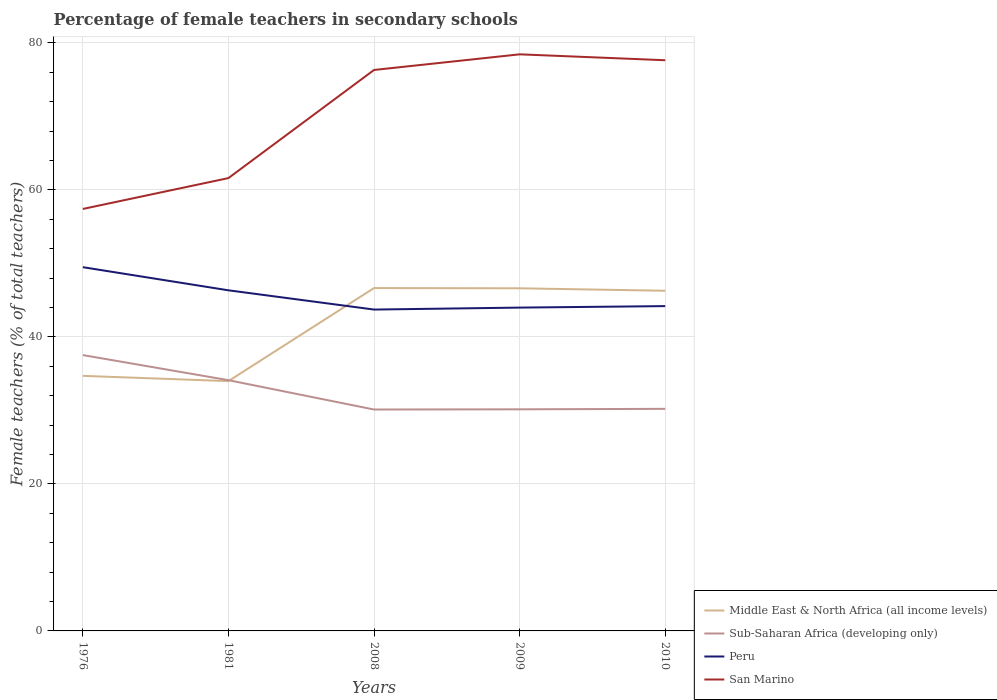How many different coloured lines are there?
Make the answer very short. 4. Is the number of lines equal to the number of legend labels?
Offer a very short reply. Yes. Across all years, what is the maximum percentage of female teachers in Middle East & North Africa (all income levels)?
Ensure brevity in your answer.  33.99. In which year was the percentage of female teachers in Sub-Saharan Africa (developing only) maximum?
Provide a succinct answer. 2008. What is the total percentage of female teachers in Middle East & North Africa (all income levels) in the graph?
Your answer should be compact. 0.72. What is the difference between the highest and the second highest percentage of female teachers in Sub-Saharan Africa (developing only)?
Make the answer very short. 7.41. How many lines are there?
Your response must be concise. 4. How many years are there in the graph?
Your answer should be compact. 5. What is the difference between two consecutive major ticks on the Y-axis?
Provide a succinct answer. 20. Does the graph contain any zero values?
Provide a short and direct response. No. Does the graph contain grids?
Make the answer very short. Yes. How many legend labels are there?
Your answer should be very brief. 4. What is the title of the graph?
Give a very brief answer. Percentage of female teachers in secondary schools. Does "Grenada" appear as one of the legend labels in the graph?
Keep it short and to the point. No. What is the label or title of the Y-axis?
Offer a very short reply. Female teachers (% of total teachers). What is the Female teachers (% of total teachers) of Middle East & North Africa (all income levels) in 1976?
Offer a very short reply. 34.7. What is the Female teachers (% of total teachers) in Sub-Saharan Africa (developing only) in 1976?
Your response must be concise. 37.53. What is the Female teachers (% of total teachers) of Peru in 1976?
Your answer should be very brief. 49.49. What is the Female teachers (% of total teachers) in San Marino in 1976?
Your answer should be very brief. 57.41. What is the Female teachers (% of total teachers) of Middle East & North Africa (all income levels) in 1981?
Provide a succinct answer. 33.99. What is the Female teachers (% of total teachers) in Sub-Saharan Africa (developing only) in 1981?
Your answer should be compact. 34.11. What is the Female teachers (% of total teachers) in Peru in 1981?
Offer a terse response. 46.34. What is the Female teachers (% of total teachers) of San Marino in 1981?
Offer a terse response. 61.61. What is the Female teachers (% of total teachers) of Middle East & North Africa (all income levels) in 2008?
Your response must be concise. 46.65. What is the Female teachers (% of total teachers) of Sub-Saharan Africa (developing only) in 2008?
Keep it short and to the point. 30.12. What is the Female teachers (% of total teachers) of Peru in 2008?
Your answer should be very brief. 43.72. What is the Female teachers (% of total teachers) of San Marino in 2008?
Offer a terse response. 76.32. What is the Female teachers (% of total teachers) of Middle East & North Africa (all income levels) in 2009?
Provide a short and direct response. 46.61. What is the Female teachers (% of total teachers) of Sub-Saharan Africa (developing only) in 2009?
Your response must be concise. 30.15. What is the Female teachers (% of total teachers) in Peru in 2009?
Your answer should be compact. 43.99. What is the Female teachers (% of total teachers) in San Marino in 2009?
Ensure brevity in your answer.  78.44. What is the Female teachers (% of total teachers) of Middle East & North Africa (all income levels) in 2010?
Your answer should be compact. 46.28. What is the Female teachers (% of total teachers) of Sub-Saharan Africa (developing only) in 2010?
Offer a terse response. 30.21. What is the Female teachers (% of total teachers) of Peru in 2010?
Keep it short and to the point. 44.19. What is the Female teachers (% of total teachers) of San Marino in 2010?
Your answer should be very brief. 77.64. Across all years, what is the maximum Female teachers (% of total teachers) of Middle East & North Africa (all income levels)?
Keep it short and to the point. 46.65. Across all years, what is the maximum Female teachers (% of total teachers) in Sub-Saharan Africa (developing only)?
Your answer should be compact. 37.53. Across all years, what is the maximum Female teachers (% of total teachers) of Peru?
Your response must be concise. 49.49. Across all years, what is the maximum Female teachers (% of total teachers) in San Marino?
Your answer should be very brief. 78.44. Across all years, what is the minimum Female teachers (% of total teachers) in Middle East & North Africa (all income levels)?
Make the answer very short. 33.99. Across all years, what is the minimum Female teachers (% of total teachers) in Sub-Saharan Africa (developing only)?
Make the answer very short. 30.12. Across all years, what is the minimum Female teachers (% of total teachers) of Peru?
Your answer should be compact. 43.72. Across all years, what is the minimum Female teachers (% of total teachers) in San Marino?
Keep it short and to the point. 57.41. What is the total Female teachers (% of total teachers) in Middle East & North Africa (all income levels) in the graph?
Provide a succinct answer. 208.22. What is the total Female teachers (% of total teachers) in Sub-Saharan Africa (developing only) in the graph?
Ensure brevity in your answer.  162.13. What is the total Female teachers (% of total teachers) of Peru in the graph?
Your answer should be very brief. 227.72. What is the total Female teachers (% of total teachers) in San Marino in the graph?
Ensure brevity in your answer.  351.41. What is the difference between the Female teachers (% of total teachers) of Middle East & North Africa (all income levels) in 1976 and that in 1981?
Your answer should be compact. 0.72. What is the difference between the Female teachers (% of total teachers) in Sub-Saharan Africa (developing only) in 1976 and that in 1981?
Make the answer very short. 3.41. What is the difference between the Female teachers (% of total teachers) of Peru in 1976 and that in 1981?
Keep it short and to the point. 3.15. What is the difference between the Female teachers (% of total teachers) in San Marino in 1976 and that in 1981?
Provide a short and direct response. -4.2. What is the difference between the Female teachers (% of total teachers) of Middle East & North Africa (all income levels) in 1976 and that in 2008?
Offer a very short reply. -11.94. What is the difference between the Female teachers (% of total teachers) of Sub-Saharan Africa (developing only) in 1976 and that in 2008?
Provide a succinct answer. 7.41. What is the difference between the Female teachers (% of total teachers) in Peru in 1976 and that in 2008?
Ensure brevity in your answer.  5.77. What is the difference between the Female teachers (% of total teachers) in San Marino in 1976 and that in 2008?
Keep it short and to the point. -18.91. What is the difference between the Female teachers (% of total teachers) of Middle East & North Africa (all income levels) in 1976 and that in 2009?
Make the answer very short. -11.91. What is the difference between the Female teachers (% of total teachers) of Sub-Saharan Africa (developing only) in 1976 and that in 2009?
Ensure brevity in your answer.  7.38. What is the difference between the Female teachers (% of total teachers) of Peru in 1976 and that in 2009?
Your answer should be compact. 5.5. What is the difference between the Female teachers (% of total teachers) of San Marino in 1976 and that in 2009?
Make the answer very short. -21.04. What is the difference between the Female teachers (% of total teachers) in Middle East & North Africa (all income levels) in 1976 and that in 2010?
Offer a very short reply. -11.58. What is the difference between the Female teachers (% of total teachers) in Sub-Saharan Africa (developing only) in 1976 and that in 2010?
Your response must be concise. 7.31. What is the difference between the Female teachers (% of total teachers) in Peru in 1976 and that in 2010?
Keep it short and to the point. 5.3. What is the difference between the Female teachers (% of total teachers) in San Marino in 1976 and that in 2010?
Your answer should be very brief. -20.23. What is the difference between the Female teachers (% of total teachers) in Middle East & North Africa (all income levels) in 1981 and that in 2008?
Provide a succinct answer. -12.66. What is the difference between the Female teachers (% of total teachers) in Sub-Saharan Africa (developing only) in 1981 and that in 2008?
Give a very brief answer. 3.99. What is the difference between the Female teachers (% of total teachers) in Peru in 1981 and that in 2008?
Provide a succinct answer. 2.62. What is the difference between the Female teachers (% of total teachers) in San Marino in 1981 and that in 2008?
Offer a terse response. -14.71. What is the difference between the Female teachers (% of total teachers) of Middle East & North Africa (all income levels) in 1981 and that in 2009?
Ensure brevity in your answer.  -12.63. What is the difference between the Female teachers (% of total teachers) in Sub-Saharan Africa (developing only) in 1981 and that in 2009?
Your response must be concise. 3.96. What is the difference between the Female teachers (% of total teachers) in Peru in 1981 and that in 2009?
Keep it short and to the point. 2.35. What is the difference between the Female teachers (% of total teachers) of San Marino in 1981 and that in 2009?
Your response must be concise. -16.84. What is the difference between the Female teachers (% of total teachers) of Middle East & North Africa (all income levels) in 1981 and that in 2010?
Provide a succinct answer. -12.29. What is the difference between the Female teachers (% of total teachers) in Sub-Saharan Africa (developing only) in 1981 and that in 2010?
Make the answer very short. 3.9. What is the difference between the Female teachers (% of total teachers) of Peru in 1981 and that in 2010?
Your response must be concise. 2.15. What is the difference between the Female teachers (% of total teachers) in San Marino in 1981 and that in 2010?
Make the answer very short. -16.03. What is the difference between the Female teachers (% of total teachers) in Middle East & North Africa (all income levels) in 2008 and that in 2009?
Give a very brief answer. 0.03. What is the difference between the Female teachers (% of total teachers) in Sub-Saharan Africa (developing only) in 2008 and that in 2009?
Offer a very short reply. -0.03. What is the difference between the Female teachers (% of total teachers) of Peru in 2008 and that in 2009?
Offer a terse response. -0.27. What is the difference between the Female teachers (% of total teachers) in San Marino in 2008 and that in 2009?
Provide a succinct answer. -2.13. What is the difference between the Female teachers (% of total teachers) of Middle East & North Africa (all income levels) in 2008 and that in 2010?
Keep it short and to the point. 0.37. What is the difference between the Female teachers (% of total teachers) in Sub-Saharan Africa (developing only) in 2008 and that in 2010?
Make the answer very short. -0.09. What is the difference between the Female teachers (% of total teachers) in Peru in 2008 and that in 2010?
Provide a succinct answer. -0.47. What is the difference between the Female teachers (% of total teachers) of San Marino in 2008 and that in 2010?
Make the answer very short. -1.32. What is the difference between the Female teachers (% of total teachers) of Middle East & North Africa (all income levels) in 2009 and that in 2010?
Keep it short and to the point. 0.34. What is the difference between the Female teachers (% of total teachers) in Sub-Saharan Africa (developing only) in 2009 and that in 2010?
Provide a short and direct response. -0.06. What is the difference between the Female teachers (% of total teachers) in Peru in 2009 and that in 2010?
Offer a terse response. -0.2. What is the difference between the Female teachers (% of total teachers) in San Marino in 2009 and that in 2010?
Keep it short and to the point. 0.8. What is the difference between the Female teachers (% of total teachers) in Middle East & North Africa (all income levels) in 1976 and the Female teachers (% of total teachers) in Sub-Saharan Africa (developing only) in 1981?
Provide a succinct answer. 0.59. What is the difference between the Female teachers (% of total teachers) in Middle East & North Africa (all income levels) in 1976 and the Female teachers (% of total teachers) in Peru in 1981?
Provide a short and direct response. -11.64. What is the difference between the Female teachers (% of total teachers) of Middle East & North Africa (all income levels) in 1976 and the Female teachers (% of total teachers) of San Marino in 1981?
Ensure brevity in your answer.  -26.91. What is the difference between the Female teachers (% of total teachers) of Sub-Saharan Africa (developing only) in 1976 and the Female teachers (% of total teachers) of Peru in 1981?
Your answer should be very brief. -8.81. What is the difference between the Female teachers (% of total teachers) of Sub-Saharan Africa (developing only) in 1976 and the Female teachers (% of total teachers) of San Marino in 1981?
Provide a short and direct response. -24.08. What is the difference between the Female teachers (% of total teachers) of Peru in 1976 and the Female teachers (% of total teachers) of San Marino in 1981?
Your answer should be very brief. -12.12. What is the difference between the Female teachers (% of total teachers) of Middle East & North Africa (all income levels) in 1976 and the Female teachers (% of total teachers) of Sub-Saharan Africa (developing only) in 2008?
Make the answer very short. 4.58. What is the difference between the Female teachers (% of total teachers) of Middle East & North Africa (all income levels) in 1976 and the Female teachers (% of total teachers) of Peru in 2008?
Your answer should be compact. -9.02. What is the difference between the Female teachers (% of total teachers) of Middle East & North Africa (all income levels) in 1976 and the Female teachers (% of total teachers) of San Marino in 2008?
Make the answer very short. -41.61. What is the difference between the Female teachers (% of total teachers) in Sub-Saharan Africa (developing only) in 1976 and the Female teachers (% of total teachers) in Peru in 2008?
Provide a short and direct response. -6.19. What is the difference between the Female teachers (% of total teachers) of Sub-Saharan Africa (developing only) in 1976 and the Female teachers (% of total teachers) of San Marino in 2008?
Offer a terse response. -38.79. What is the difference between the Female teachers (% of total teachers) in Peru in 1976 and the Female teachers (% of total teachers) in San Marino in 2008?
Your answer should be compact. -26.83. What is the difference between the Female teachers (% of total teachers) in Middle East & North Africa (all income levels) in 1976 and the Female teachers (% of total teachers) in Sub-Saharan Africa (developing only) in 2009?
Keep it short and to the point. 4.55. What is the difference between the Female teachers (% of total teachers) in Middle East & North Africa (all income levels) in 1976 and the Female teachers (% of total teachers) in Peru in 2009?
Provide a short and direct response. -9.29. What is the difference between the Female teachers (% of total teachers) of Middle East & North Africa (all income levels) in 1976 and the Female teachers (% of total teachers) of San Marino in 2009?
Offer a very short reply. -43.74. What is the difference between the Female teachers (% of total teachers) in Sub-Saharan Africa (developing only) in 1976 and the Female teachers (% of total teachers) in Peru in 2009?
Ensure brevity in your answer.  -6.46. What is the difference between the Female teachers (% of total teachers) of Sub-Saharan Africa (developing only) in 1976 and the Female teachers (% of total teachers) of San Marino in 2009?
Offer a very short reply. -40.92. What is the difference between the Female teachers (% of total teachers) in Peru in 1976 and the Female teachers (% of total teachers) in San Marino in 2009?
Your response must be concise. -28.96. What is the difference between the Female teachers (% of total teachers) of Middle East & North Africa (all income levels) in 1976 and the Female teachers (% of total teachers) of Sub-Saharan Africa (developing only) in 2010?
Your response must be concise. 4.49. What is the difference between the Female teachers (% of total teachers) of Middle East & North Africa (all income levels) in 1976 and the Female teachers (% of total teachers) of Peru in 2010?
Make the answer very short. -9.49. What is the difference between the Female teachers (% of total teachers) of Middle East & North Africa (all income levels) in 1976 and the Female teachers (% of total teachers) of San Marino in 2010?
Provide a short and direct response. -42.94. What is the difference between the Female teachers (% of total teachers) of Sub-Saharan Africa (developing only) in 1976 and the Female teachers (% of total teachers) of Peru in 2010?
Make the answer very short. -6.66. What is the difference between the Female teachers (% of total teachers) in Sub-Saharan Africa (developing only) in 1976 and the Female teachers (% of total teachers) in San Marino in 2010?
Provide a succinct answer. -40.11. What is the difference between the Female teachers (% of total teachers) of Peru in 1976 and the Female teachers (% of total teachers) of San Marino in 2010?
Your response must be concise. -28.15. What is the difference between the Female teachers (% of total teachers) of Middle East & North Africa (all income levels) in 1981 and the Female teachers (% of total teachers) of Sub-Saharan Africa (developing only) in 2008?
Ensure brevity in your answer.  3.86. What is the difference between the Female teachers (% of total teachers) of Middle East & North Africa (all income levels) in 1981 and the Female teachers (% of total teachers) of Peru in 2008?
Offer a very short reply. -9.73. What is the difference between the Female teachers (% of total teachers) in Middle East & North Africa (all income levels) in 1981 and the Female teachers (% of total teachers) in San Marino in 2008?
Your response must be concise. -42.33. What is the difference between the Female teachers (% of total teachers) of Sub-Saharan Africa (developing only) in 1981 and the Female teachers (% of total teachers) of Peru in 2008?
Ensure brevity in your answer.  -9.61. What is the difference between the Female teachers (% of total teachers) of Sub-Saharan Africa (developing only) in 1981 and the Female teachers (% of total teachers) of San Marino in 2008?
Provide a succinct answer. -42.2. What is the difference between the Female teachers (% of total teachers) in Peru in 1981 and the Female teachers (% of total teachers) in San Marino in 2008?
Your response must be concise. -29.98. What is the difference between the Female teachers (% of total teachers) in Middle East & North Africa (all income levels) in 1981 and the Female teachers (% of total teachers) in Sub-Saharan Africa (developing only) in 2009?
Give a very brief answer. 3.84. What is the difference between the Female teachers (% of total teachers) of Middle East & North Africa (all income levels) in 1981 and the Female teachers (% of total teachers) of Peru in 2009?
Provide a short and direct response. -10. What is the difference between the Female teachers (% of total teachers) of Middle East & North Africa (all income levels) in 1981 and the Female teachers (% of total teachers) of San Marino in 2009?
Your answer should be very brief. -44.46. What is the difference between the Female teachers (% of total teachers) of Sub-Saharan Africa (developing only) in 1981 and the Female teachers (% of total teachers) of Peru in 2009?
Make the answer very short. -9.87. What is the difference between the Female teachers (% of total teachers) in Sub-Saharan Africa (developing only) in 1981 and the Female teachers (% of total teachers) in San Marino in 2009?
Offer a very short reply. -44.33. What is the difference between the Female teachers (% of total teachers) of Peru in 1981 and the Female teachers (% of total teachers) of San Marino in 2009?
Offer a very short reply. -32.1. What is the difference between the Female teachers (% of total teachers) of Middle East & North Africa (all income levels) in 1981 and the Female teachers (% of total teachers) of Sub-Saharan Africa (developing only) in 2010?
Your response must be concise. 3.77. What is the difference between the Female teachers (% of total teachers) of Middle East & North Africa (all income levels) in 1981 and the Female teachers (% of total teachers) of Peru in 2010?
Give a very brief answer. -10.2. What is the difference between the Female teachers (% of total teachers) in Middle East & North Africa (all income levels) in 1981 and the Female teachers (% of total teachers) in San Marino in 2010?
Make the answer very short. -43.65. What is the difference between the Female teachers (% of total teachers) in Sub-Saharan Africa (developing only) in 1981 and the Female teachers (% of total teachers) in Peru in 2010?
Keep it short and to the point. -10.08. What is the difference between the Female teachers (% of total teachers) of Sub-Saharan Africa (developing only) in 1981 and the Female teachers (% of total teachers) of San Marino in 2010?
Provide a succinct answer. -43.53. What is the difference between the Female teachers (% of total teachers) of Peru in 1981 and the Female teachers (% of total teachers) of San Marino in 2010?
Your answer should be very brief. -31.3. What is the difference between the Female teachers (% of total teachers) in Middle East & North Africa (all income levels) in 2008 and the Female teachers (% of total teachers) in Sub-Saharan Africa (developing only) in 2009?
Your response must be concise. 16.5. What is the difference between the Female teachers (% of total teachers) in Middle East & North Africa (all income levels) in 2008 and the Female teachers (% of total teachers) in Peru in 2009?
Offer a very short reply. 2.66. What is the difference between the Female teachers (% of total teachers) in Middle East & North Africa (all income levels) in 2008 and the Female teachers (% of total teachers) in San Marino in 2009?
Keep it short and to the point. -31.8. What is the difference between the Female teachers (% of total teachers) in Sub-Saharan Africa (developing only) in 2008 and the Female teachers (% of total teachers) in Peru in 2009?
Offer a terse response. -13.87. What is the difference between the Female teachers (% of total teachers) in Sub-Saharan Africa (developing only) in 2008 and the Female teachers (% of total teachers) in San Marino in 2009?
Your answer should be compact. -48.32. What is the difference between the Female teachers (% of total teachers) of Peru in 2008 and the Female teachers (% of total teachers) of San Marino in 2009?
Offer a terse response. -34.72. What is the difference between the Female teachers (% of total teachers) of Middle East & North Africa (all income levels) in 2008 and the Female teachers (% of total teachers) of Sub-Saharan Africa (developing only) in 2010?
Your answer should be compact. 16.43. What is the difference between the Female teachers (% of total teachers) of Middle East & North Africa (all income levels) in 2008 and the Female teachers (% of total teachers) of Peru in 2010?
Offer a terse response. 2.46. What is the difference between the Female teachers (% of total teachers) of Middle East & North Africa (all income levels) in 2008 and the Female teachers (% of total teachers) of San Marino in 2010?
Your response must be concise. -30.99. What is the difference between the Female teachers (% of total teachers) of Sub-Saharan Africa (developing only) in 2008 and the Female teachers (% of total teachers) of Peru in 2010?
Your answer should be very brief. -14.07. What is the difference between the Female teachers (% of total teachers) of Sub-Saharan Africa (developing only) in 2008 and the Female teachers (% of total teachers) of San Marino in 2010?
Provide a short and direct response. -47.52. What is the difference between the Female teachers (% of total teachers) of Peru in 2008 and the Female teachers (% of total teachers) of San Marino in 2010?
Your answer should be very brief. -33.92. What is the difference between the Female teachers (% of total teachers) in Middle East & North Africa (all income levels) in 2009 and the Female teachers (% of total teachers) in Sub-Saharan Africa (developing only) in 2010?
Provide a short and direct response. 16.4. What is the difference between the Female teachers (% of total teachers) in Middle East & North Africa (all income levels) in 2009 and the Female teachers (% of total teachers) in Peru in 2010?
Provide a succinct answer. 2.42. What is the difference between the Female teachers (% of total teachers) in Middle East & North Africa (all income levels) in 2009 and the Female teachers (% of total teachers) in San Marino in 2010?
Make the answer very short. -31.03. What is the difference between the Female teachers (% of total teachers) of Sub-Saharan Africa (developing only) in 2009 and the Female teachers (% of total teachers) of Peru in 2010?
Your answer should be very brief. -14.04. What is the difference between the Female teachers (% of total teachers) of Sub-Saharan Africa (developing only) in 2009 and the Female teachers (% of total teachers) of San Marino in 2010?
Your answer should be compact. -47.49. What is the difference between the Female teachers (% of total teachers) of Peru in 2009 and the Female teachers (% of total teachers) of San Marino in 2010?
Your answer should be compact. -33.65. What is the average Female teachers (% of total teachers) of Middle East & North Africa (all income levels) per year?
Keep it short and to the point. 41.64. What is the average Female teachers (% of total teachers) of Sub-Saharan Africa (developing only) per year?
Your answer should be very brief. 32.43. What is the average Female teachers (% of total teachers) of Peru per year?
Make the answer very short. 45.54. What is the average Female teachers (% of total teachers) in San Marino per year?
Provide a short and direct response. 70.28. In the year 1976, what is the difference between the Female teachers (% of total teachers) of Middle East & North Africa (all income levels) and Female teachers (% of total teachers) of Sub-Saharan Africa (developing only)?
Keep it short and to the point. -2.83. In the year 1976, what is the difference between the Female teachers (% of total teachers) in Middle East & North Africa (all income levels) and Female teachers (% of total teachers) in Peru?
Offer a very short reply. -14.79. In the year 1976, what is the difference between the Female teachers (% of total teachers) of Middle East & North Africa (all income levels) and Female teachers (% of total teachers) of San Marino?
Provide a succinct answer. -22.71. In the year 1976, what is the difference between the Female teachers (% of total teachers) in Sub-Saharan Africa (developing only) and Female teachers (% of total teachers) in Peru?
Offer a very short reply. -11.96. In the year 1976, what is the difference between the Female teachers (% of total teachers) in Sub-Saharan Africa (developing only) and Female teachers (% of total teachers) in San Marino?
Give a very brief answer. -19.88. In the year 1976, what is the difference between the Female teachers (% of total teachers) in Peru and Female teachers (% of total teachers) in San Marino?
Provide a succinct answer. -7.92. In the year 1981, what is the difference between the Female teachers (% of total teachers) of Middle East & North Africa (all income levels) and Female teachers (% of total teachers) of Sub-Saharan Africa (developing only)?
Offer a terse response. -0.13. In the year 1981, what is the difference between the Female teachers (% of total teachers) of Middle East & North Africa (all income levels) and Female teachers (% of total teachers) of Peru?
Your answer should be compact. -12.35. In the year 1981, what is the difference between the Female teachers (% of total teachers) in Middle East & North Africa (all income levels) and Female teachers (% of total teachers) in San Marino?
Provide a short and direct response. -27.62. In the year 1981, what is the difference between the Female teachers (% of total teachers) in Sub-Saharan Africa (developing only) and Female teachers (% of total teachers) in Peru?
Offer a very short reply. -12.23. In the year 1981, what is the difference between the Female teachers (% of total teachers) in Sub-Saharan Africa (developing only) and Female teachers (% of total teachers) in San Marino?
Provide a short and direct response. -27.49. In the year 1981, what is the difference between the Female teachers (% of total teachers) of Peru and Female teachers (% of total teachers) of San Marino?
Ensure brevity in your answer.  -15.27. In the year 2008, what is the difference between the Female teachers (% of total teachers) in Middle East & North Africa (all income levels) and Female teachers (% of total teachers) in Sub-Saharan Africa (developing only)?
Provide a succinct answer. 16.52. In the year 2008, what is the difference between the Female teachers (% of total teachers) of Middle East & North Africa (all income levels) and Female teachers (% of total teachers) of Peru?
Keep it short and to the point. 2.92. In the year 2008, what is the difference between the Female teachers (% of total teachers) of Middle East & North Africa (all income levels) and Female teachers (% of total teachers) of San Marino?
Offer a terse response. -29.67. In the year 2008, what is the difference between the Female teachers (% of total teachers) in Sub-Saharan Africa (developing only) and Female teachers (% of total teachers) in Peru?
Give a very brief answer. -13.6. In the year 2008, what is the difference between the Female teachers (% of total teachers) of Sub-Saharan Africa (developing only) and Female teachers (% of total teachers) of San Marino?
Your response must be concise. -46.19. In the year 2008, what is the difference between the Female teachers (% of total teachers) of Peru and Female teachers (% of total teachers) of San Marino?
Your answer should be very brief. -32.6. In the year 2009, what is the difference between the Female teachers (% of total teachers) in Middle East & North Africa (all income levels) and Female teachers (% of total teachers) in Sub-Saharan Africa (developing only)?
Ensure brevity in your answer.  16.46. In the year 2009, what is the difference between the Female teachers (% of total teachers) in Middle East & North Africa (all income levels) and Female teachers (% of total teachers) in Peru?
Your response must be concise. 2.63. In the year 2009, what is the difference between the Female teachers (% of total teachers) of Middle East & North Africa (all income levels) and Female teachers (% of total teachers) of San Marino?
Give a very brief answer. -31.83. In the year 2009, what is the difference between the Female teachers (% of total teachers) of Sub-Saharan Africa (developing only) and Female teachers (% of total teachers) of Peru?
Your response must be concise. -13.84. In the year 2009, what is the difference between the Female teachers (% of total teachers) of Sub-Saharan Africa (developing only) and Female teachers (% of total teachers) of San Marino?
Keep it short and to the point. -48.29. In the year 2009, what is the difference between the Female teachers (% of total teachers) of Peru and Female teachers (% of total teachers) of San Marino?
Your answer should be very brief. -34.46. In the year 2010, what is the difference between the Female teachers (% of total teachers) of Middle East & North Africa (all income levels) and Female teachers (% of total teachers) of Sub-Saharan Africa (developing only)?
Your answer should be very brief. 16.06. In the year 2010, what is the difference between the Female teachers (% of total teachers) in Middle East & North Africa (all income levels) and Female teachers (% of total teachers) in Peru?
Your response must be concise. 2.09. In the year 2010, what is the difference between the Female teachers (% of total teachers) in Middle East & North Africa (all income levels) and Female teachers (% of total teachers) in San Marino?
Make the answer very short. -31.36. In the year 2010, what is the difference between the Female teachers (% of total teachers) in Sub-Saharan Africa (developing only) and Female teachers (% of total teachers) in Peru?
Offer a very short reply. -13.98. In the year 2010, what is the difference between the Female teachers (% of total teachers) of Sub-Saharan Africa (developing only) and Female teachers (% of total teachers) of San Marino?
Keep it short and to the point. -47.43. In the year 2010, what is the difference between the Female teachers (% of total teachers) in Peru and Female teachers (% of total teachers) in San Marino?
Make the answer very short. -33.45. What is the ratio of the Female teachers (% of total teachers) in Middle East & North Africa (all income levels) in 1976 to that in 1981?
Offer a terse response. 1.02. What is the ratio of the Female teachers (% of total teachers) in Sub-Saharan Africa (developing only) in 1976 to that in 1981?
Offer a terse response. 1.1. What is the ratio of the Female teachers (% of total teachers) of Peru in 1976 to that in 1981?
Offer a very short reply. 1.07. What is the ratio of the Female teachers (% of total teachers) of San Marino in 1976 to that in 1981?
Give a very brief answer. 0.93. What is the ratio of the Female teachers (% of total teachers) in Middle East & North Africa (all income levels) in 1976 to that in 2008?
Your answer should be compact. 0.74. What is the ratio of the Female teachers (% of total teachers) of Sub-Saharan Africa (developing only) in 1976 to that in 2008?
Give a very brief answer. 1.25. What is the ratio of the Female teachers (% of total teachers) of Peru in 1976 to that in 2008?
Your answer should be very brief. 1.13. What is the ratio of the Female teachers (% of total teachers) in San Marino in 1976 to that in 2008?
Your answer should be very brief. 0.75. What is the ratio of the Female teachers (% of total teachers) of Middle East & North Africa (all income levels) in 1976 to that in 2009?
Ensure brevity in your answer.  0.74. What is the ratio of the Female teachers (% of total teachers) in Sub-Saharan Africa (developing only) in 1976 to that in 2009?
Your response must be concise. 1.24. What is the ratio of the Female teachers (% of total teachers) in San Marino in 1976 to that in 2009?
Provide a succinct answer. 0.73. What is the ratio of the Female teachers (% of total teachers) of Middle East & North Africa (all income levels) in 1976 to that in 2010?
Offer a very short reply. 0.75. What is the ratio of the Female teachers (% of total teachers) of Sub-Saharan Africa (developing only) in 1976 to that in 2010?
Offer a terse response. 1.24. What is the ratio of the Female teachers (% of total teachers) in Peru in 1976 to that in 2010?
Keep it short and to the point. 1.12. What is the ratio of the Female teachers (% of total teachers) of San Marino in 1976 to that in 2010?
Your answer should be compact. 0.74. What is the ratio of the Female teachers (% of total teachers) in Middle East & North Africa (all income levels) in 1981 to that in 2008?
Provide a short and direct response. 0.73. What is the ratio of the Female teachers (% of total teachers) of Sub-Saharan Africa (developing only) in 1981 to that in 2008?
Your answer should be compact. 1.13. What is the ratio of the Female teachers (% of total teachers) of Peru in 1981 to that in 2008?
Make the answer very short. 1.06. What is the ratio of the Female teachers (% of total teachers) of San Marino in 1981 to that in 2008?
Provide a succinct answer. 0.81. What is the ratio of the Female teachers (% of total teachers) of Middle East & North Africa (all income levels) in 1981 to that in 2009?
Your answer should be compact. 0.73. What is the ratio of the Female teachers (% of total teachers) in Sub-Saharan Africa (developing only) in 1981 to that in 2009?
Provide a succinct answer. 1.13. What is the ratio of the Female teachers (% of total teachers) in Peru in 1981 to that in 2009?
Your response must be concise. 1.05. What is the ratio of the Female teachers (% of total teachers) in San Marino in 1981 to that in 2009?
Provide a short and direct response. 0.79. What is the ratio of the Female teachers (% of total teachers) in Middle East & North Africa (all income levels) in 1981 to that in 2010?
Make the answer very short. 0.73. What is the ratio of the Female teachers (% of total teachers) of Sub-Saharan Africa (developing only) in 1981 to that in 2010?
Your answer should be very brief. 1.13. What is the ratio of the Female teachers (% of total teachers) of Peru in 1981 to that in 2010?
Your response must be concise. 1.05. What is the ratio of the Female teachers (% of total teachers) of San Marino in 1981 to that in 2010?
Offer a terse response. 0.79. What is the ratio of the Female teachers (% of total teachers) of Middle East & North Africa (all income levels) in 2008 to that in 2009?
Offer a very short reply. 1. What is the ratio of the Female teachers (% of total teachers) in Sub-Saharan Africa (developing only) in 2008 to that in 2009?
Ensure brevity in your answer.  1. What is the ratio of the Female teachers (% of total teachers) of San Marino in 2008 to that in 2009?
Give a very brief answer. 0.97. What is the ratio of the Female teachers (% of total teachers) in Middle East & North Africa (all income levels) in 2008 to that in 2010?
Provide a short and direct response. 1.01. What is the ratio of the Female teachers (% of total teachers) in San Marino in 2008 to that in 2010?
Provide a short and direct response. 0.98. What is the ratio of the Female teachers (% of total teachers) of Middle East & North Africa (all income levels) in 2009 to that in 2010?
Your answer should be compact. 1.01. What is the ratio of the Female teachers (% of total teachers) of Sub-Saharan Africa (developing only) in 2009 to that in 2010?
Provide a short and direct response. 1. What is the ratio of the Female teachers (% of total teachers) of San Marino in 2009 to that in 2010?
Offer a terse response. 1.01. What is the difference between the highest and the second highest Female teachers (% of total teachers) of Middle East & North Africa (all income levels)?
Give a very brief answer. 0.03. What is the difference between the highest and the second highest Female teachers (% of total teachers) of Sub-Saharan Africa (developing only)?
Ensure brevity in your answer.  3.41. What is the difference between the highest and the second highest Female teachers (% of total teachers) in Peru?
Offer a very short reply. 3.15. What is the difference between the highest and the second highest Female teachers (% of total teachers) in San Marino?
Give a very brief answer. 0.8. What is the difference between the highest and the lowest Female teachers (% of total teachers) of Middle East & North Africa (all income levels)?
Your answer should be compact. 12.66. What is the difference between the highest and the lowest Female teachers (% of total teachers) in Sub-Saharan Africa (developing only)?
Offer a very short reply. 7.41. What is the difference between the highest and the lowest Female teachers (% of total teachers) of Peru?
Offer a terse response. 5.77. What is the difference between the highest and the lowest Female teachers (% of total teachers) of San Marino?
Keep it short and to the point. 21.04. 